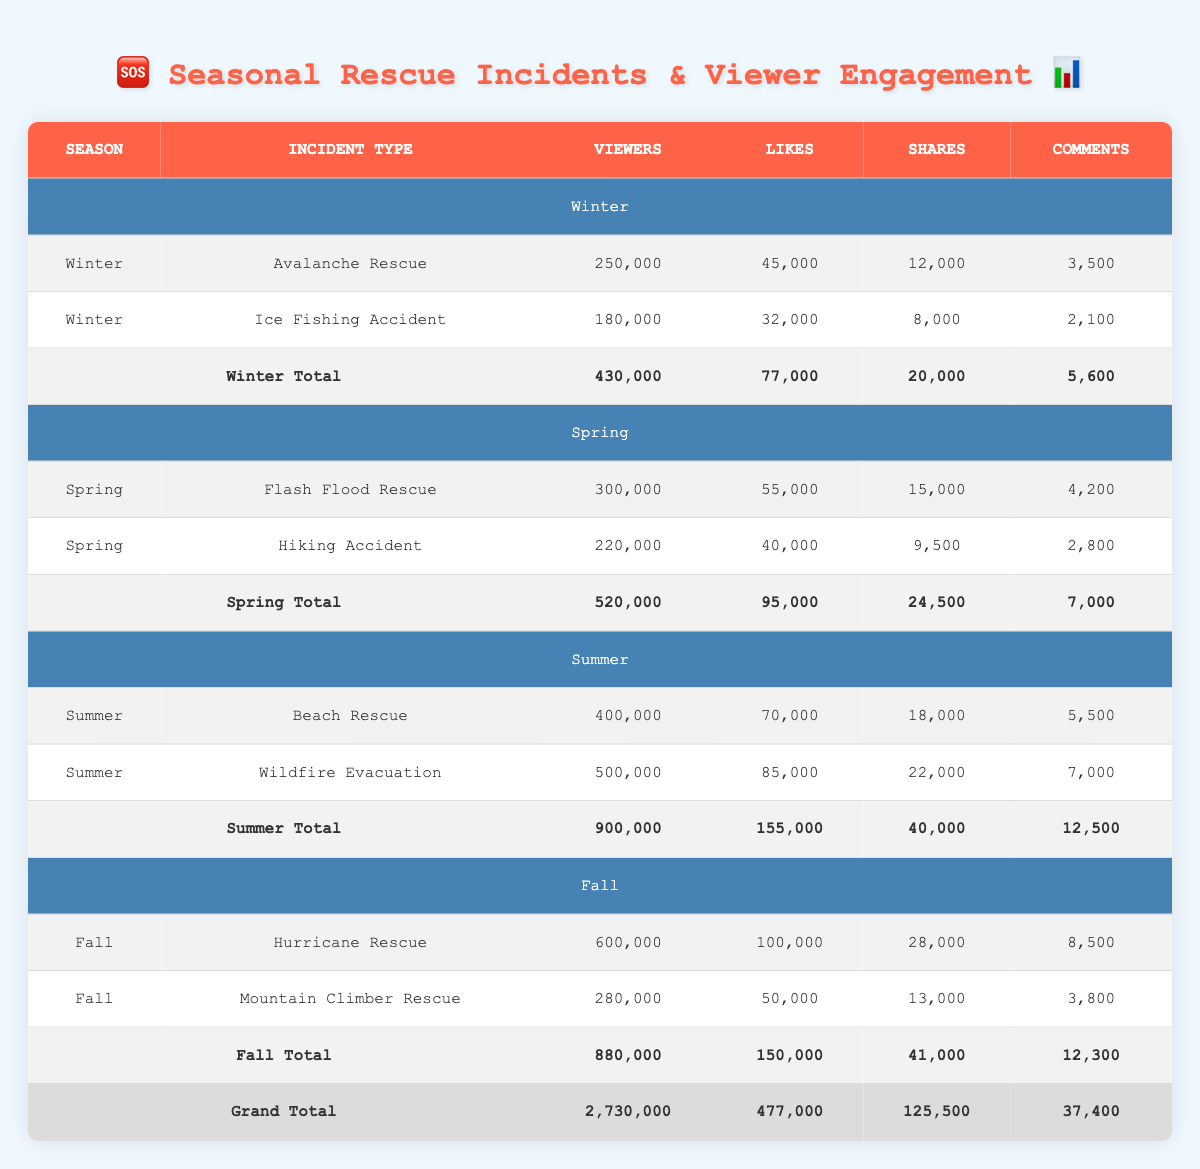What is the total number of viewers for Winter rescue incidents? For Winter, the table lists two incidents: Avalanche Rescue with 250,000 viewers and Ice Fishing Accident with 180,000 viewers. Adding these gives us 250,000 + 180,000 = 430,000 viewers in total.
Answer: 430,000 Which rescue incident in Fall garnered the most viewers? In the Fall section, there are two incidents: Hurricane Rescue with 600,000 viewers and Mountain Climber Rescue with 280,000 viewers. The higher number is 600,000 for the Hurricane Rescue.
Answer: Hurricane Rescue What was the total number of likes for Spring incidents? In Spring, there are two incidents: Flash Flood Rescue with 55,000 likes and Hiking Accident with 40,000 likes. The total is calculated as 55,000 + 40,000 = 95,000 likes.
Answer: 95,000 Is the number of viewers for Summer rescues higher than the total number of viewers for Winter rescues? For Summer, there are two incidents totaling 900,000 viewers (Beach Rescue with 400,000 and Wildfire Evacuation with 500,000). For Winter, there are 430,000 viewers. Since 900,000 is greater than 430,000, the statement is true.
Answer: Yes What is the difference in the number of comments between the most and least commented incidents across all seasons? The most commented incident is Hurricane Rescue with 8,500 comments and the least is Ice Fishing Accident with 2,100 comments. The difference is 8,500 - 2,100 = 6,400 comments.
Answer: 6,400 Which season had the highest total number of shares across all incidents? The table shows shares for each season: Winter has 20,000, Spring has 24,500, Summer has 40,000, and Fall has 41,000. The highest number of shares is in Fall with 41,000.
Answer: Fall How many total comments were made across all incidents in the dataset? To find the total comments, we sum up comments from each incident: 3,500 (Winter) + 2,100 (Winter) + 4,200 (Spring) + 2,800 (Spring) + 5,500 (Summer) + 7,000 (Summer) + 8,500 (Fall) + 3,800 (Fall) = 37,400 comments in total.
Answer: 37,400 What is the average viewers per incident for Spring? In Spring, there are 2 incidents: Flash Flood Rescue (300,000 viewers) and Hiking Accident (220,000 viewers). The total viewers are 520,000. The average is 520,000 / 2 = 260,000 viewers.
Answer: 260,000 Does the total number of viewers for Fall incidents exceed 800,000? For Fall incidents, the total number of viewers is 880,000 (600,000 for Hurricane Rescue and 280,000 for Mountain Climber Rescue). Since 880,000 is greater than 800,000, the answer is yes.
Answer: Yes 